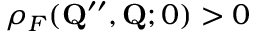<formula> <loc_0><loc_0><loc_500><loc_500>\rho _ { F } ( Q ^ { \prime \prime } , Q ; 0 ) > 0</formula> 